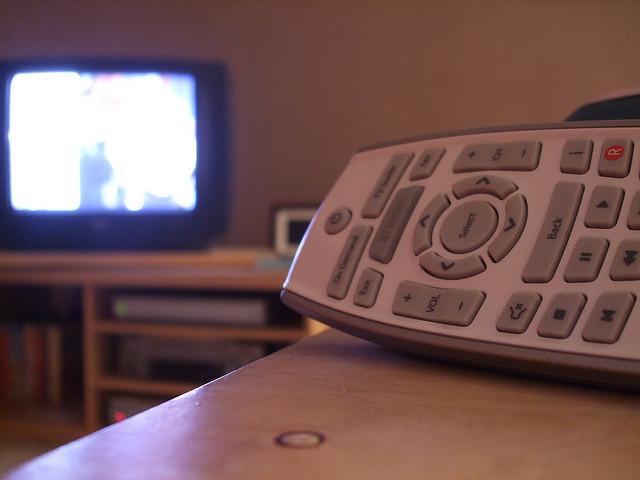How many controls are in the picture?
Give a very brief answer. 1. How many people are in the picture?
Give a very brief answer. 0. 